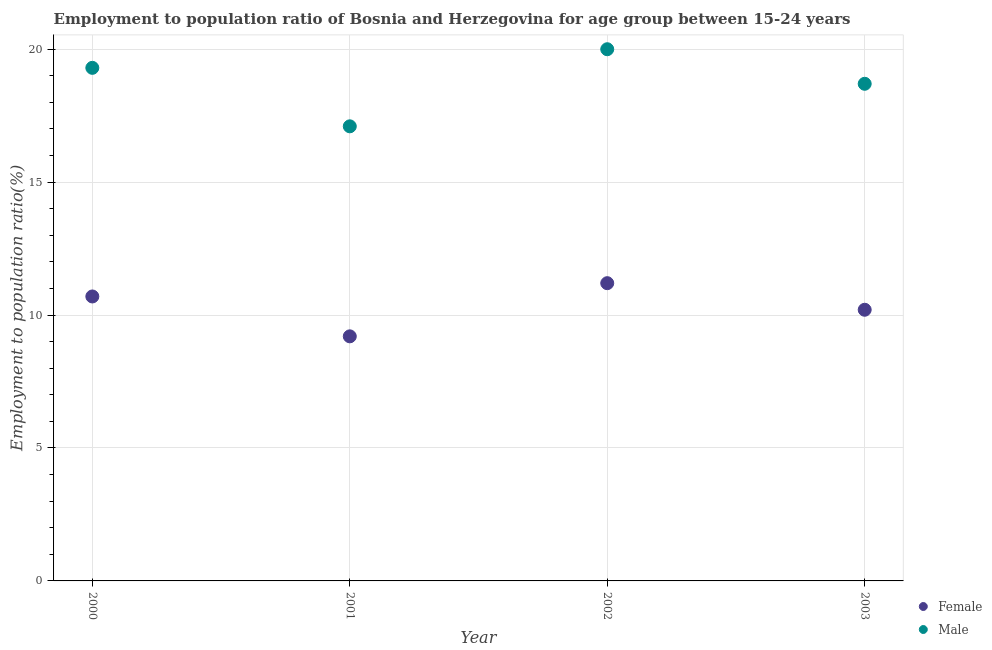How many different coloured dotlines are there?
Keep it short and to the point. 2. Is the number of dotlines equal to the number of legend labels?
Your answer should be very brief. Yes. What is the employment to population ratio(female) in 2003?
Ensure brevity in your answer.  10.2. Across all years, what is the maximum employment to population ratio(female)?
Make the answer very short. 11.2. Across all years, what is the minimum employment to population ratio(female)?
Ensure brevity in your answer.  9.2. In which year was the employment to population ratio(female) maximum?
Provide a short and direct response. 2002. In which year was the employment to population ratio(female) minimum?
Your answer should be very brief. 2001. What is the total employment to population ratio(female) in the graph?
Your response must be concise. 41.3. What is the difference between the employment to population ratio(male) in 2002 and that in 2003?
Provide a succinct answer. 1.3. What is the difference between the employment to population ratio(female) in 2003 and the employment to population ratio(male) in 2002?
Your answer should be compact. -9.8. What is the average employment to population ratio(male) per year?
Your answer should be compact. 18.78. In the year 2001, what is the difference between the employment to population ratio(female) and employment to population ratio(male)?
Offer a very short reply. -7.9. In how many years, is the employment to population ratio(female) greater than 12 %?
Give a very brief answer. 0. What is the ratio of the employment to population ratio(female) in 2002 to that in 2003?
Keep it short and to the point. 1.1. What is the difference between the highest and the second highest employment to population ratio(male)?
Your answer should be very brief. 0.7. What is the difference between the highest and the lowest employment to population ratio(female)?
Make the answer very short. 2. In how many years, is the employment to population ratio(male) greater than the average employment to population ratio(male) taken over all years?
Offer a very short reply. 2. Is the sum of the employment to population ratio(female) in 2001 and 2002 greater than the maximum employment to population ratio(male) across all years?
Ensure brevity in your answer.  Yes. Does the employment to population ratio(female) monotonically increase over the years?
Your answer should be very brief. No. Is the employment to population ratio(female) strictly greater than the employment to population ratio(male) over the years?
Ensure brevity in your answer.  No. Is the employment to population ratio(female) strictly less than the employment to population ratio(male) over the years?
Ensure brevity in your answer.  Yes. How many dotlines are there?
Your answer should be very brief. 2. Does the graph contain grids?
Your response must be concise. Yes. Where does the legend appear in the graph?
Provide a short and direct response. Bottom right. What is the title of the graph?
Give a very brief answer. Employment to population ratio of Bosnia and Herzegovina for age group between 15-24 years. Does "Death rate" appear as one of the legend labels in the graph?
Keep it short and to the point. No. What is the label or title of the X-axis?
Provide a succinct answer. Year. What is the label or title of the Y-axis?
Your answer should be very brief. Employment to population ratio(%). What is the Employment to population ratio(%) in Female in 2000?
Offer a terse response. 10.7. What is the Employment to population ratio(%) of Male in 2000?
Ensure brevity in your answer.  19.3. What is the Employment to population ratio(%) in Female in 2001?
Offer a terse response. 9.2. What is the Employment to population ratio(%) in Male in 2001?
Keep it short and to the point. 17.1. What is the Employment to population ratio(%) in Female in 2002?
Give a very brief answer. 11.2. What is the Employment to population ratio(%) of Male in 2002?
Provide a short and direct response. 20. What is the Employment to population ratio(%) of Female in 2003?
Give a very brief answer. 10.2. What is the Employment to population ratio(%) in Male in 2003?
Give a very brief answer. 18.7. Across all years, what is the maximum Employment to population ratio(%) of Female?
Your response must be concise. 11.2. Across all years, what is the minimum Employment to population ratio(%) of Female?
Your response must be concise. 9.2. Across all years, what is the minimum Employment to population ratio(%) of Male?
Offer a terse response. 17.1. What is the total Employment to population ratio(%) in Female in the graph?
Your answer should be very brief. 41.3. What is the total Employment to population ratio(%) of Male in the graph?
Offer a very short reply. 75.1. What is the difference between the Employment to population ratio(%) in Female in 2000 and that in 2001?
Provide a succinct answer. 1.5. What is the difference between the Employment to population ratio(%) in Male in 2000 and that in 2002?
Provide a short and direct response. -0.7. What is the difference between the Employment to population ratio(%) of Male in 2000 and that in 2003?
Your answer should be very brief. 0.6. What is the difference between the Employment to population ratio(%) in Female in 2001 and that in 2002?
Your answer should be very brief. -2. What is the difference between the Employment to population ratio(%) in Female in 2001 and that in 2003?
Make the answer very short. -1. What is the difference between the Employment to population ratio(%) in Male in 2001 and that in 2003?
Make the answer very short. -1.6. What is the difference between the Employment to population ratio(%) of Female in 2000 and the Employment to population ratio(%) of Male in 2002?
Keep it short and to the point. -9.3. What is the difference between the Employment to population ratio(%) in Female in 2001 and the Employment to population ratio(%) in Male in 2003?
Offer a terse response. -9.5. What is the average Employment to population ratio(%) in Female per year?
Your response must be concise. 10.32. What is the average Employment to population ratio(%) in Male per year?
Keep it short and to the point. 18.77. In the year 2000, what is the difference between the Employment to population ratio(%) of Female and Employment to population ratio(%) of Male?
Offer a terse response. -8.6. What is the ratio of the Employment to population ratio(%) in Female in 2000 to that in 2001?
Your response must be concise. 1.16. What is the ratio of the Employment to population ratio(%) of Male in 2000 to that in 2001?
Give a very brief answer. 1.13. What is the ratio of the Employment to population ratio(%) of Female in 2000 to that in 2002?
Provide a succinct answer. 0.96. What is the ratio of the Employment to population ratio(%) in Female in 2000 to that in 2003?
Offer a very short reply. 1.05. What is the ratio of the Employment to population ratio(%) in Male in 2000 to that in 2003?
Make the answer very short. 1.03. What is the ratio of the Employment to population ratio(%) in Female in 2001 to that in 2002?
Provide a succinct answer. 0.82. What is the ratio of the Employment to population ratio(%) in Male in 2001 to that in 2002?
Keep it short and to the point. 0.85. What is the ratio of the Employment to population ratio(%) of Female in 2001 to that in 2003?
Your response must be concise. 0.9. What is the ratio of the Employment to population ratio(%) in Male in 2001 to that in 2003?
Provide a succinct answer. 0.91. What is the ratio of the Employment to population ratio(%) in Female in 2002 to that in 2003?
Your answer should be very brief. 1.1. What is the ratio of the Employment to population ratio(%) of Male in 2002 to that in 2003?
Offer a terse response. 1.07. What is the difference between the highest and the second highest Employment to population ratio(%) in Female?
Provide a succinct answer. 0.5. What is the difference between the highest and the second highest Employment to population ratio(%) of Male?
Make the answer very short. 0.7. 